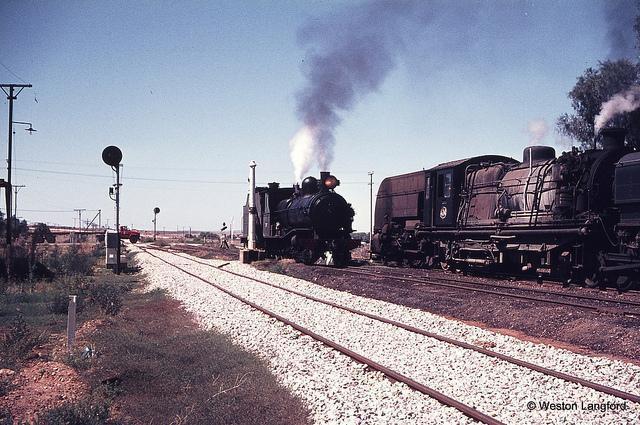How many trains are there?
Give a very brief answer. 2. 